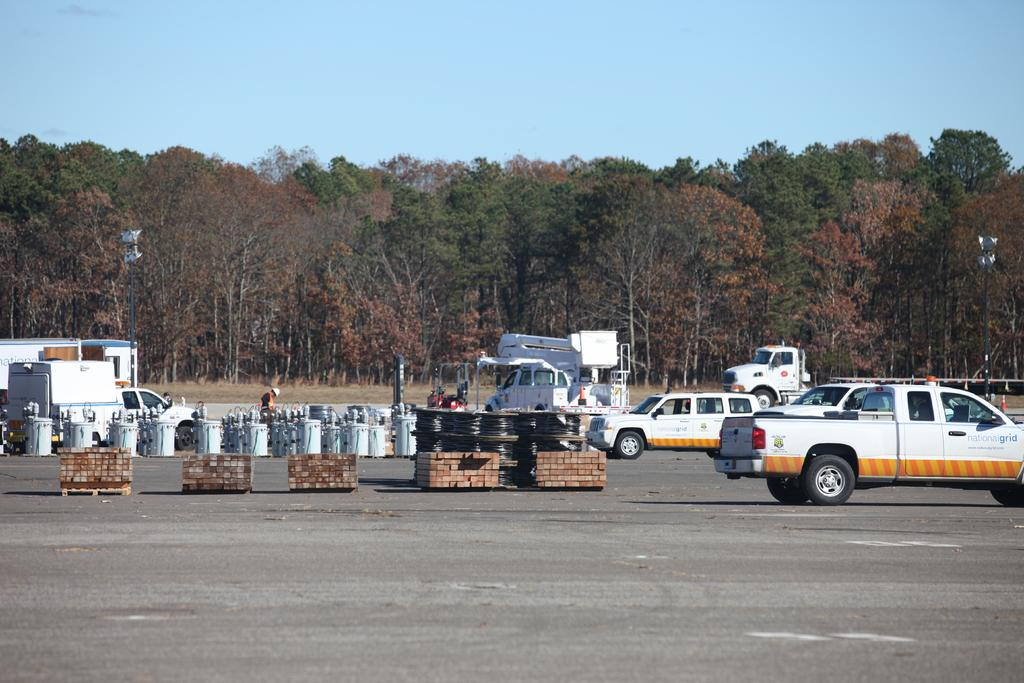What is happening on the road in the image? There are vehicles moving on the road in the image. What color are the vehicles? The vehicles are white in color. What can be seen in the background of the image? There are trees and the sky visible in the background of the image. What is the purpose of the cannon in the image? There is no cannon present in the image. How many people can fit in the lift in the image? There is no lift present in the image. 